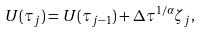<formula> <loc_0><loc_0><loc_500><loc_500>U ( \tau _ { j } ) = U ( \tau _ { j - 1 } ) + \Delta \tau ^ { 1 / \alpha } \zeta _ { j } ,</formula> 